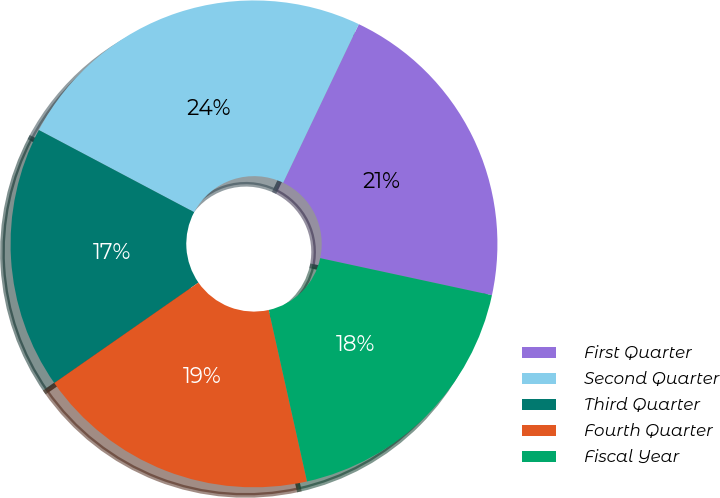<chart> <loc_0><loc_0><loc_500><loc_500><pie_chart><fcel>First Quarter<fcel>Second Quarter<fcel>Third Quarter<fcel>Fourth Quarter<fcel>Fiscal Year<nl><fcel>21.3%<fcel>24.34%<fcel>17.43%<fcel>18.81%<fcel>18.12%<nl></chart> 